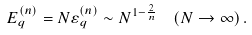Convert formula to latex. <formula><loc_0><loc_0><loc_500><loc_500>E _ { q } ^ { ( n ) } = N \varepsilon ^ { ( n ) } _ { q } \sim N ^ { 1 - \frac { 2 } { n } } \ \ ( N \rightarrow \infty ) \, .</formula> 